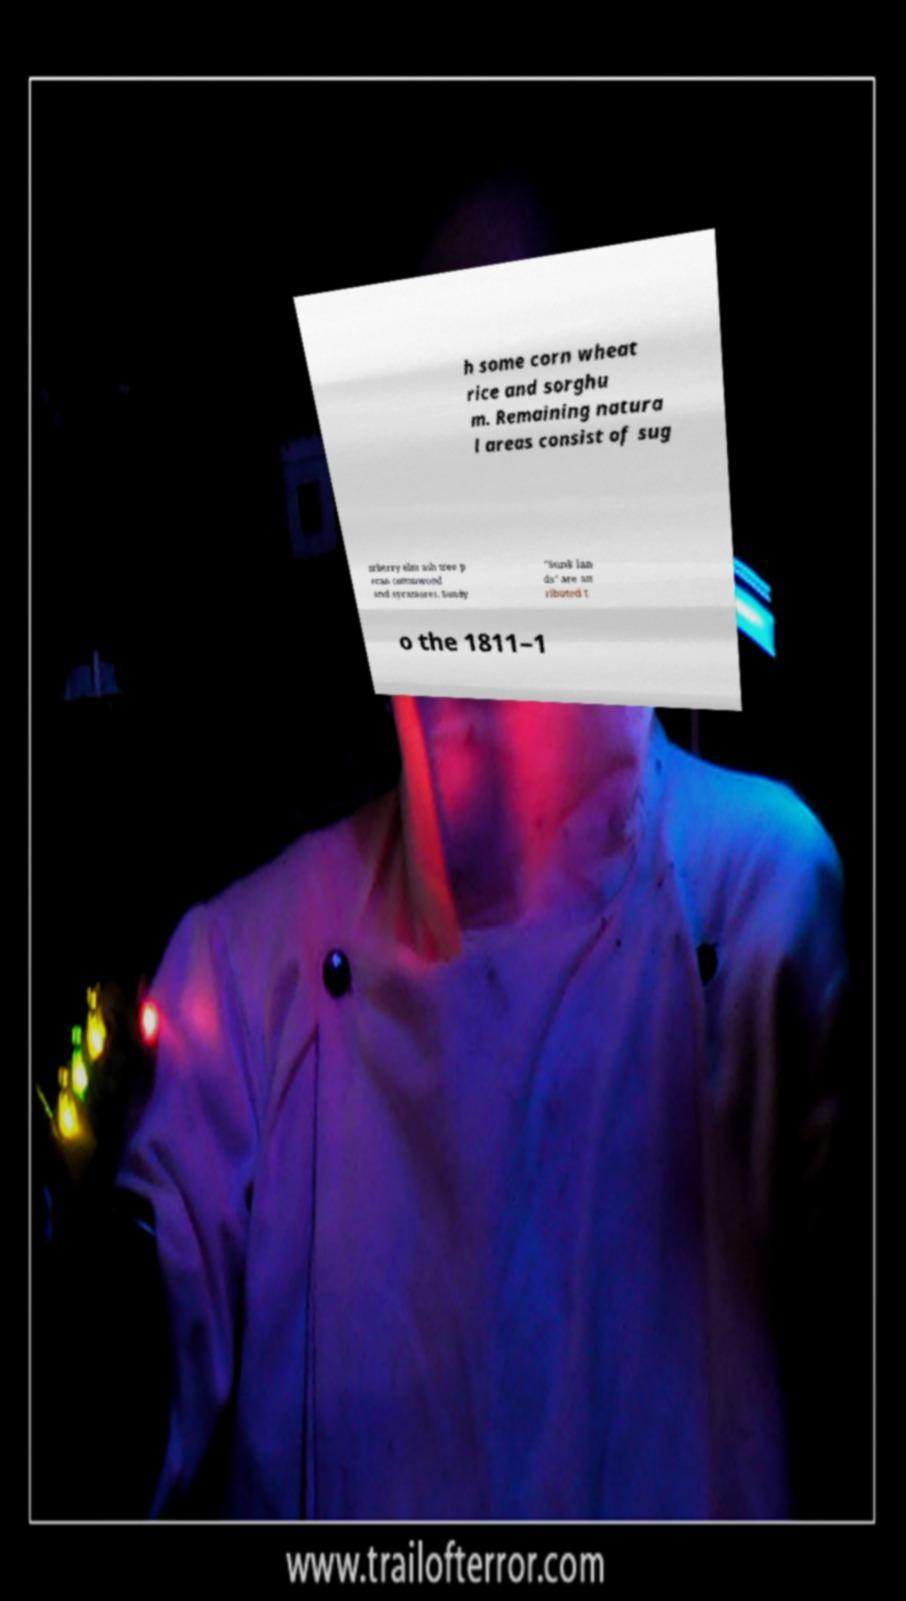Please identify and transcribe the text found in this image. h some corn wheat rice and sorghu m. Remaining natura l areas consist of sug arberry elm ash tree p ecan cottonwood and sycamores. Sandy "Sunk lan ds" are att ributed t o the 1811–1 